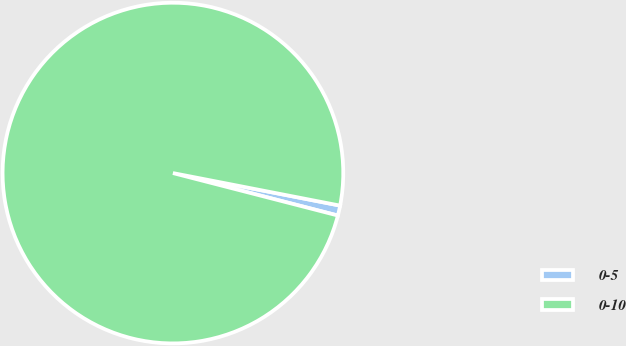Convert chart. <chart><loc_0><loc_0><loc_500><loc_500><pie_chart><fcel>0-5<fcel>0-10<nl><fcel>0.95%<fcel>99.05%<nl></chart> 